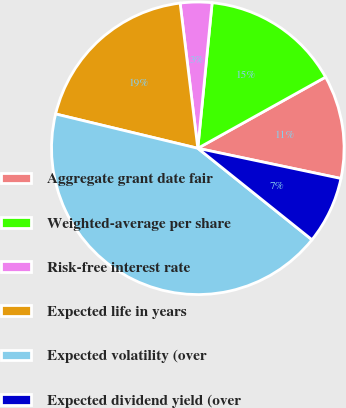Convert chart. <chart><loc_0><loc_0><loc_500><loc_500><pie_chart><fcel>Aggregate grant date fair<fcel>Weighted-average per share<fcel>Risk-free interest rate<fcel>Expected life in years<fcel>Expected volatility (over<fcel>Expected dividend yield (over<nl><fcel>11.4%<fcel>15.35%<fcel>3.49%<fcel>19.3%<fcel>43.02%<fcel>7.44%<nl></chart> 